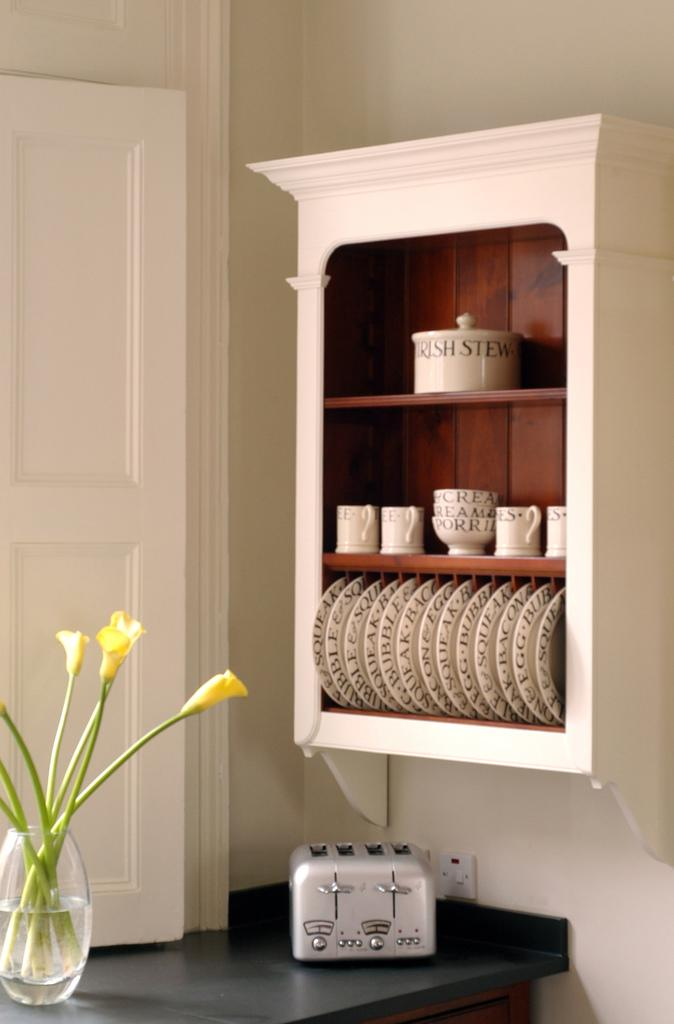<image>
Create a compact narrative representing the image presented. A four slice toaster under a plate rack that has a crock of Irish stew on the top shelf. 